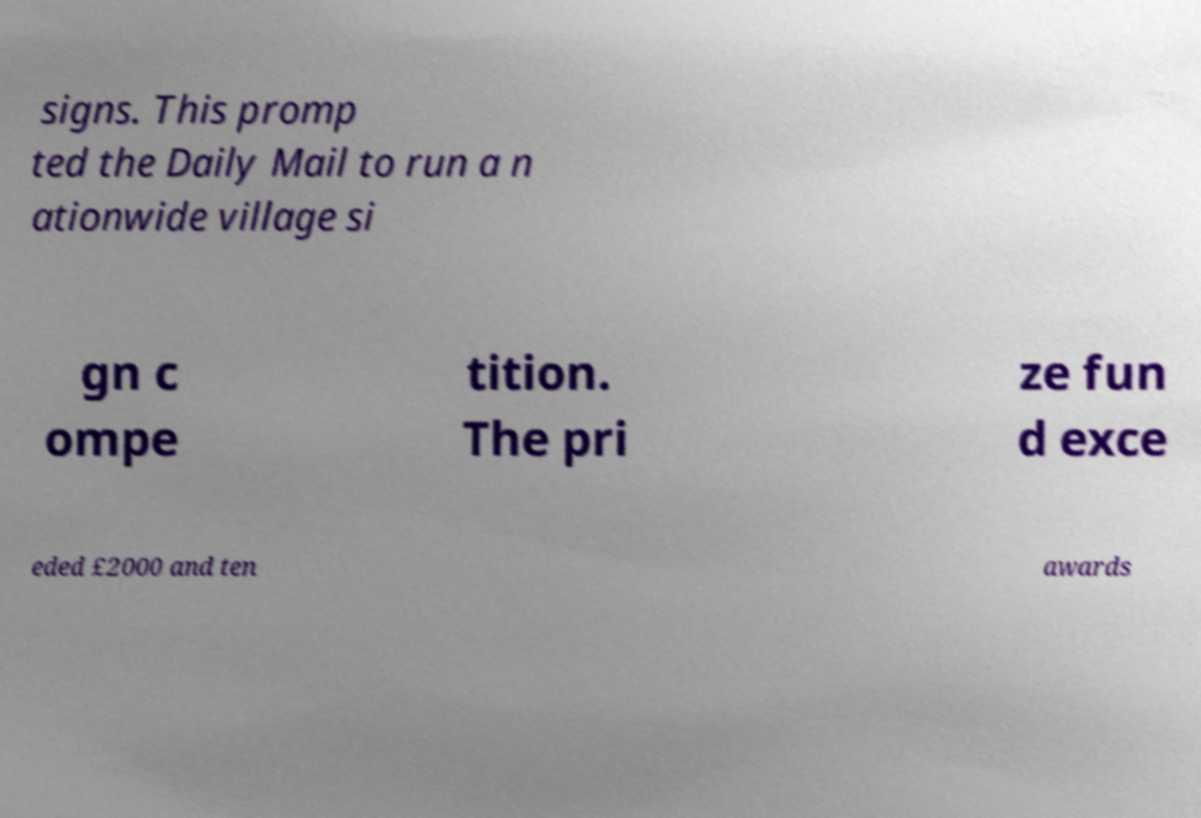I need the written content from this picture converted into text. Can you do that? signs. This promp ted the Daily Mail to run a n ationwide village si gn c ompe tition. The pri ze fun d exce eded £2000 and ten awards 